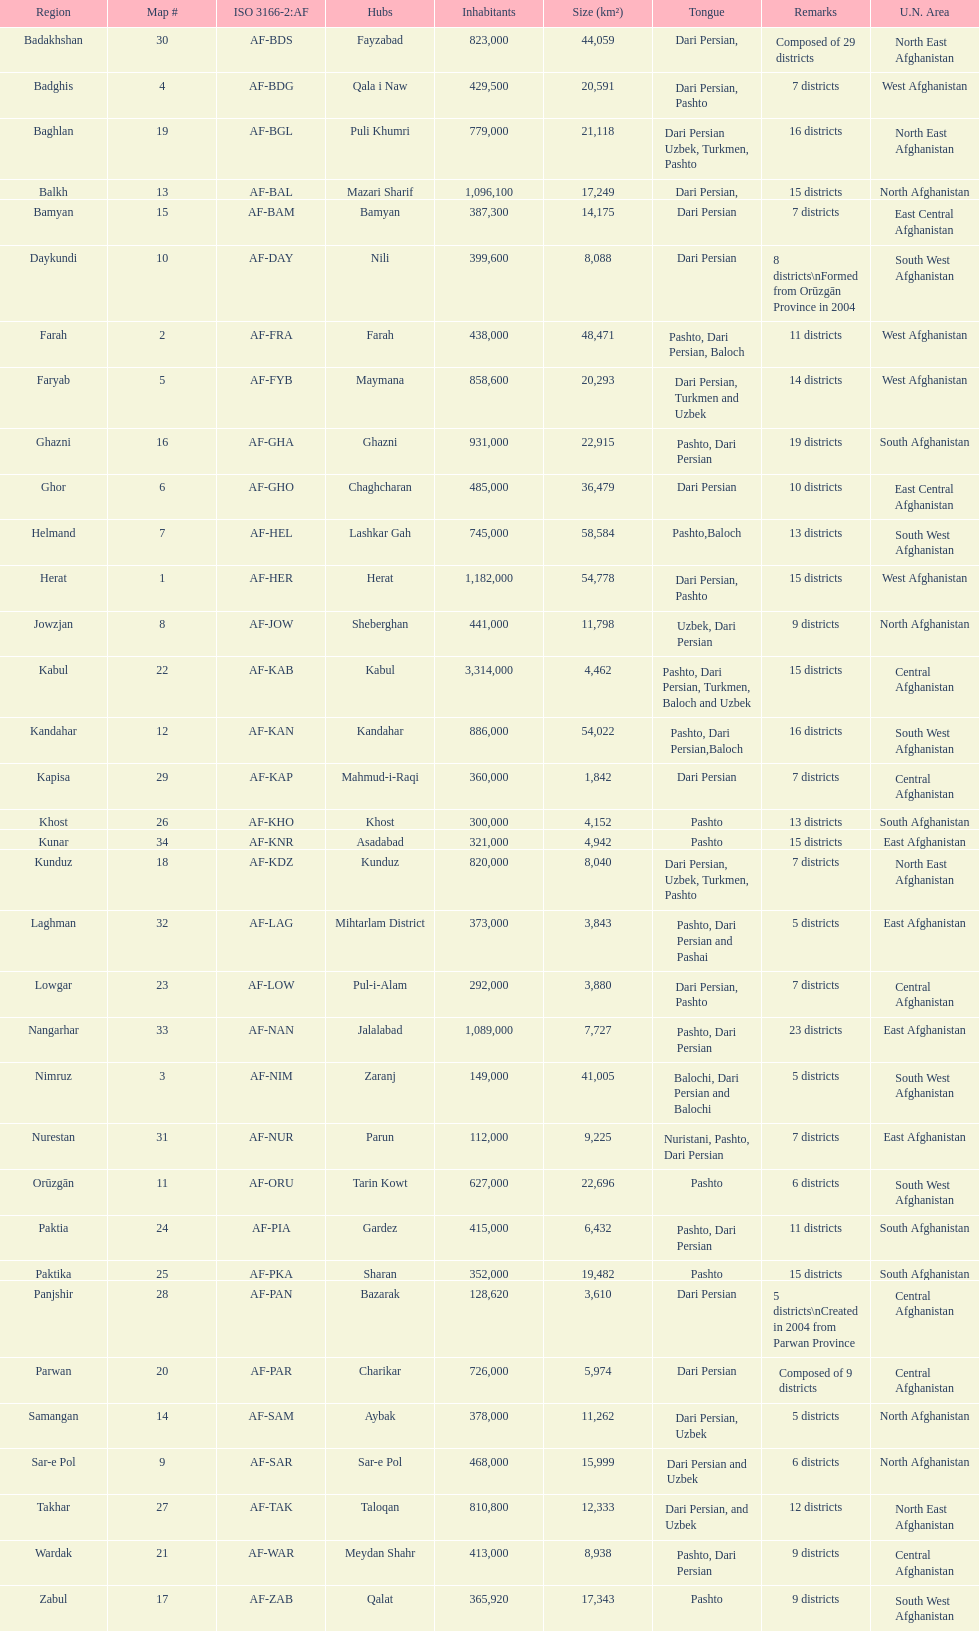Which province has the most districts? Badakhshan. 